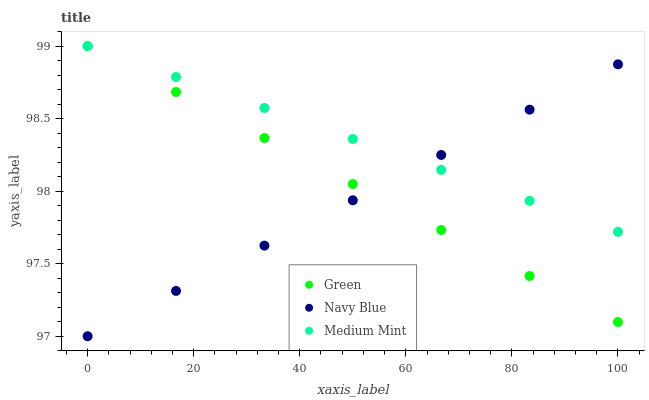Does Navy Blue have the minimum area under the curve?
Answer yes or no. Yes. Does Medium Mint have the maximum area under the curve?
Answer yes or no. Yes. Does Green have the minimum area under the curve?
Answer yes or no. No. Does Green have the maximum area under the curve?
Answer yes or no. No. Is Medium Mint the smoothest?
Answer yes or no. Yes. Is Green the roughest?
Answer yes or no. Yes. Is Navy Blue the smoothest?
Answer yes or no. No. Is Navy Blue the roughest?
Answer yes or no. No. Does Navy Blue have the lowest value?
Answer yes or no. Yes. Does Green have the lowest value?
Answer yes or no. No. Does Green have the highest value?
Answer yes or no. Yes. Does Navy Blue have the highest value?
Answer yes or no. No. Does Medium Mint intersect Green?
Answer yes or no. Yes. Is Medium Mint less than Green?
Answer yes or no. No. Is Medium Mint greater than Green?
Answer yes or no. No. 